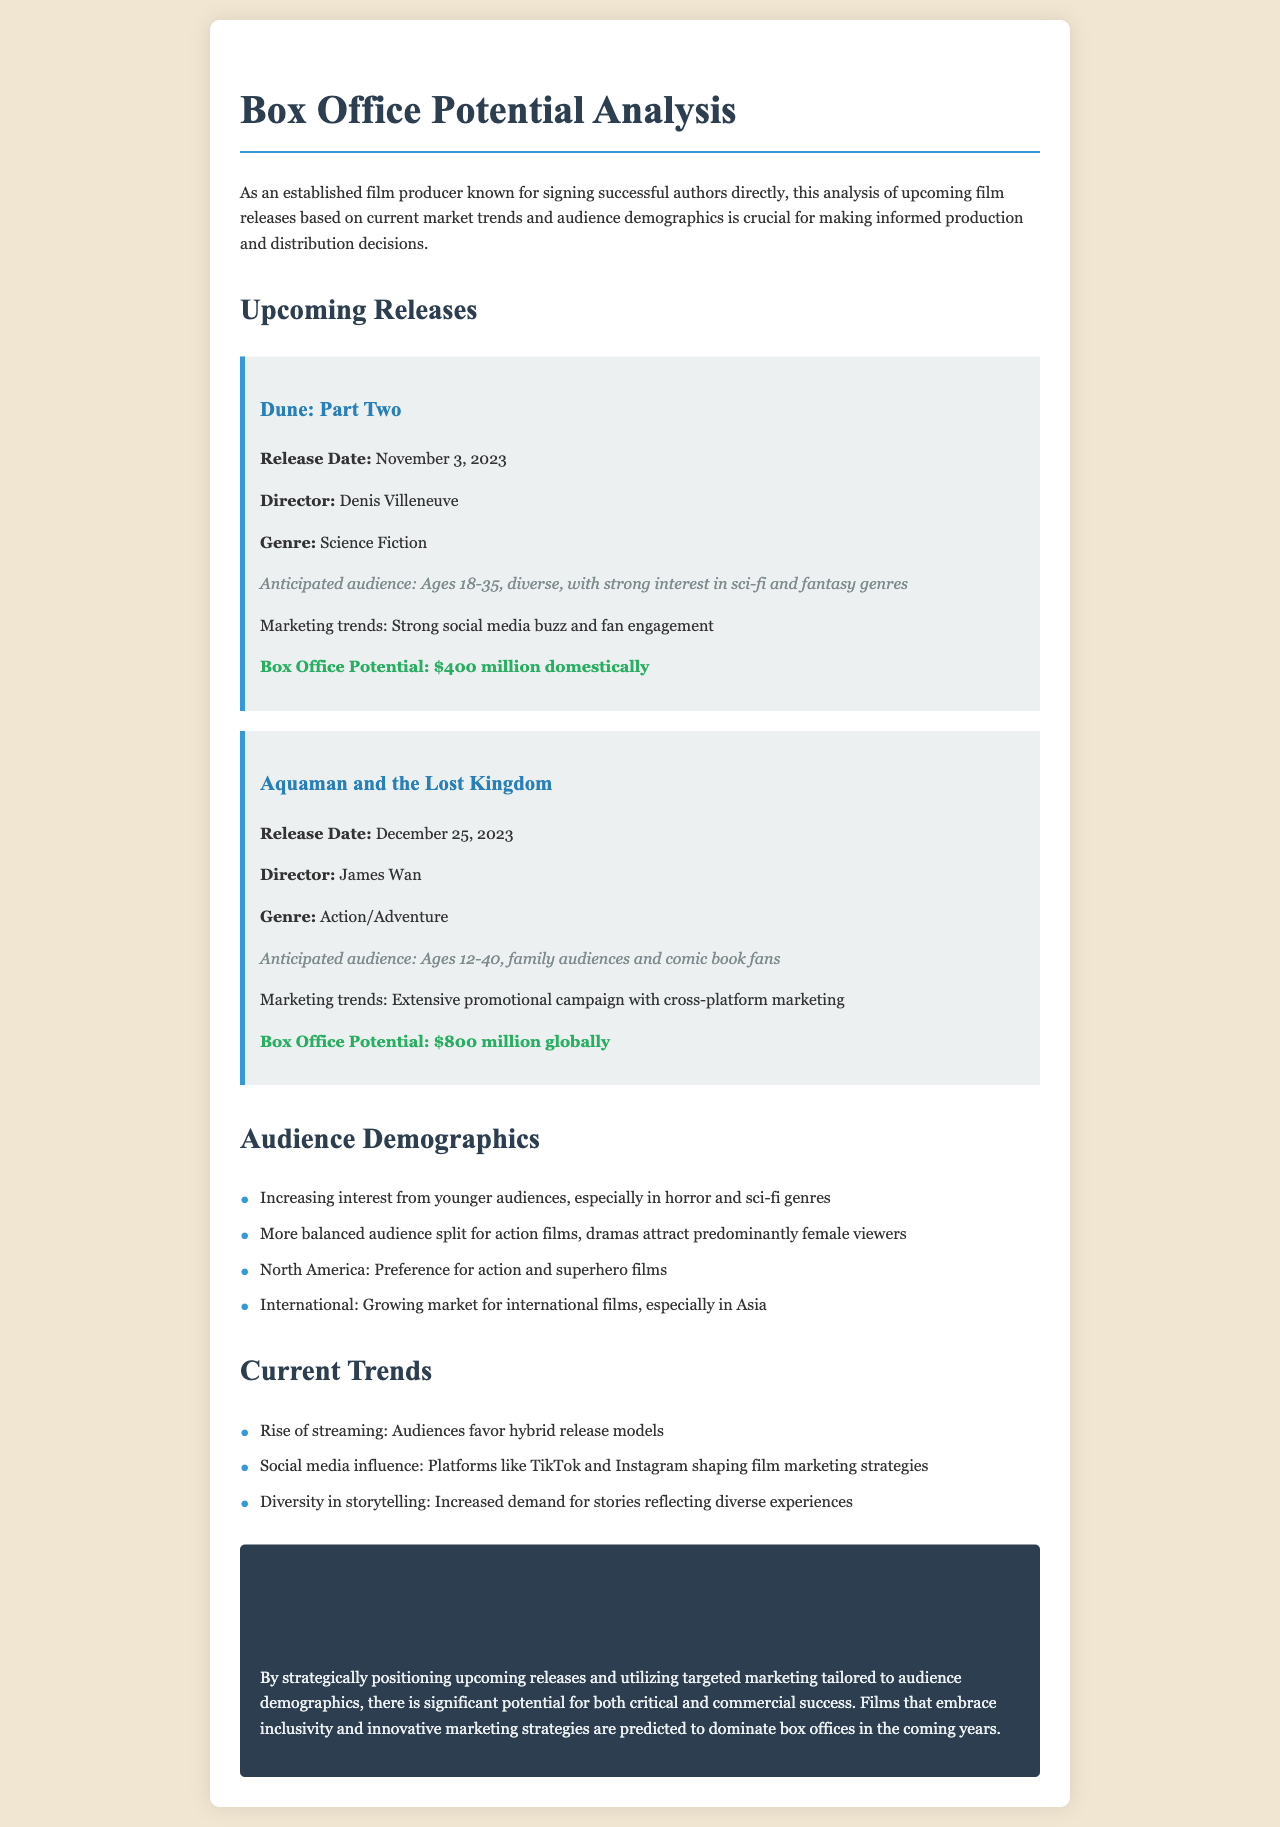What is the release date of "Dune: Part Two"? The release date is found in the section detailing upcoming releases for "Dune: Part Two".
Answer: November 3, 2023 Who is the director of "Aquaman and the Lost Kingdom"? The director's name is listed under the film card for "Aquaman and the Lost Kingdom".
Answer: James Wan What is the box office potential for "Dune: Part Two"? The box office potential is specified in dollars in the film card for "Dune: Part Two".
Answer: $400 million domestically What audience demographic is targeted by "Aquaman and the Lost Kingdom"? The anticipated audience demographic is mentioned within the film card for "Aquaman and the Lost Kingdom".
Answer: Ages 12-40, family audiences and comic book fans Which two platforms are mentioned as influential in film marketing strategies? The platforms are specifically identified in the section discussing current trends.
Answer: TikTok and Instagram What genre has an increasing interest from younger audiences? The document highlights this genre in the audience demographics section.
Answer: Horror and sci-fi What is featured as a marketing trend for "Dune: Part Two"? The marketing trends are described alongside each film in their respective sections.
Answer: Strong social media buzz and fan engagement How much is the box office potential estimated for "Aquaman and the Lost Kingdom"? The figure is mentioned explicitly in the film card for "Aquaman and the Lost Kingdom".
Answer: $800 million globally 